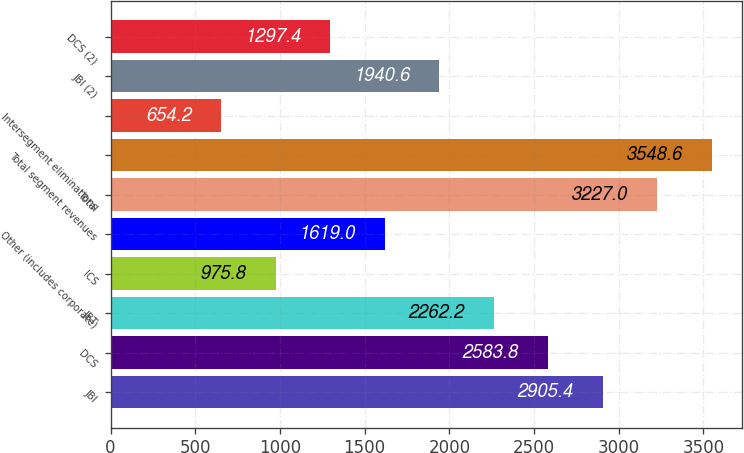Convert chart to OTSL. <chart><loc_0><loc_0><loc_500><loc_500><bar_chart><fcel>JBI<fcel>DCS<fcel>JBT<fcel>ICS<fcel>Other (includes corporate)<fcel>Total<fcel>Total segment revenues<fcel>Intersegment eliminations<fcel>JBI (2)<fcel>DCS (2)<nl><fcel>2905.4<fcel>2583.8<fcel>2262.2<fcel>975.8<fcel>1619<fcel>3227<fcel>3548.6<fcel>654.2<fcel>1940.6<fcel>1297.4<nl></chart> 